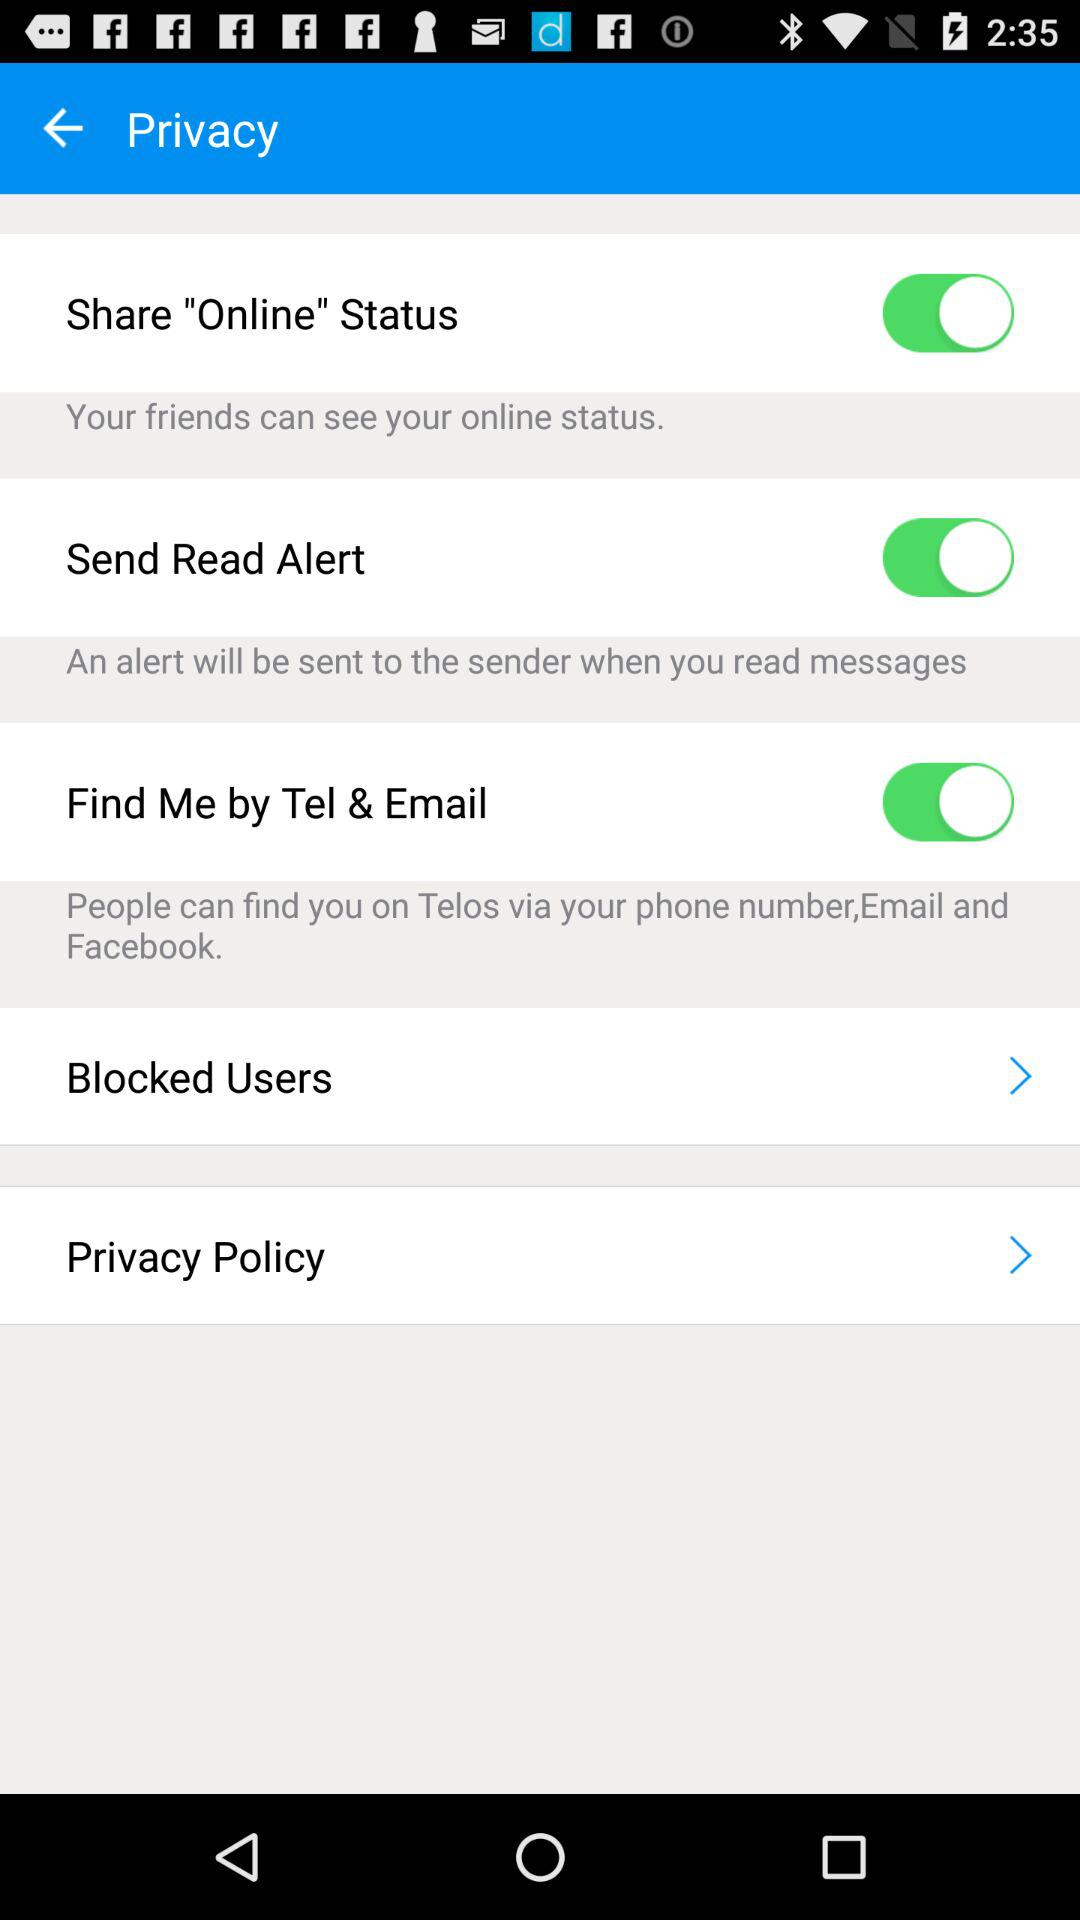Should I be concerned about any privacy issues associated with the settings in this image? It's always important to review privacy settings based on personal preference and desired level of privacy. The settings displayed allow users to control how others can locate them and whether their actions (like reading messages) are notified to others. It's crucial to understand each option and adjust them to ensure a balance between connectivity and privacy that you are comfortable with. 